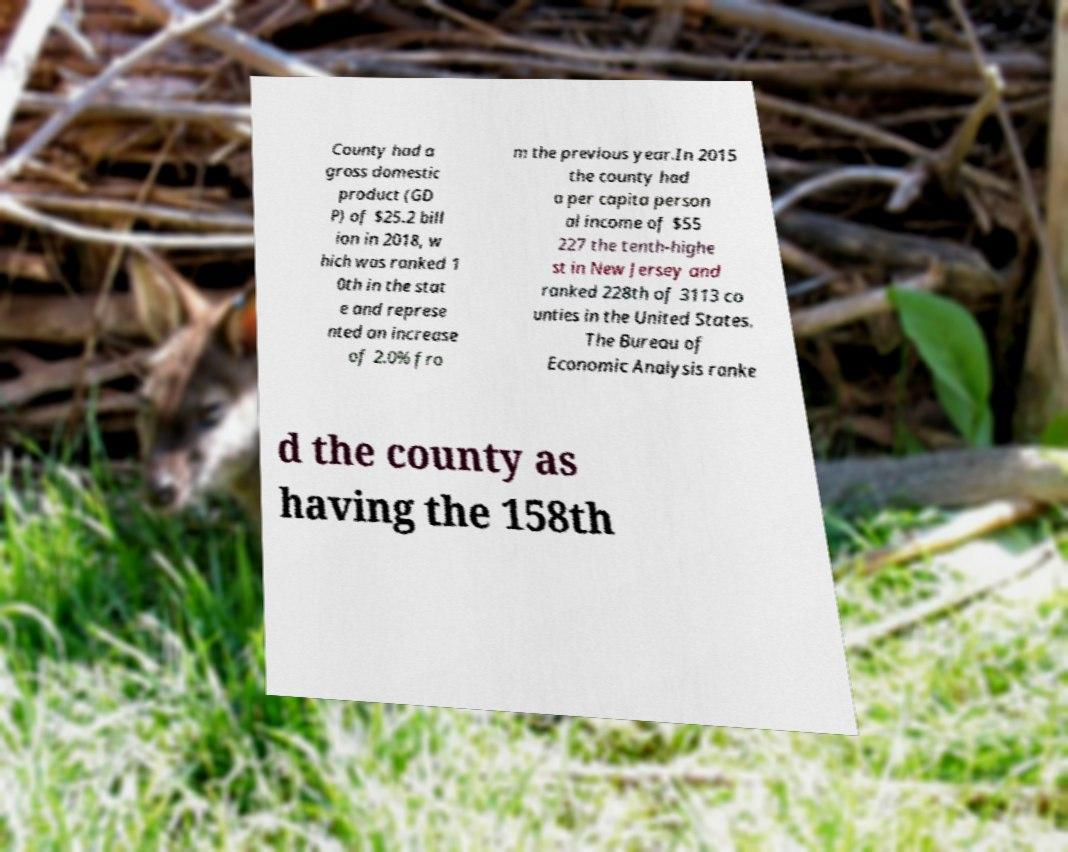Can you accurately transcribe the text from the provided image for me? County had a gross domestic product (GD P) of $25.2 bill ion in 2018, w hich was ranked 1 0th in the stat e and represe nted an increase of 2.0% fro m the previous year.In 2015 the county had a per capita person al income of $55 227 the tenth-highe st in New Jersey and ranked 228th of 3113 co unties in the United States. The Bureau of Economic Analysis ranke d the county as having the 158th 